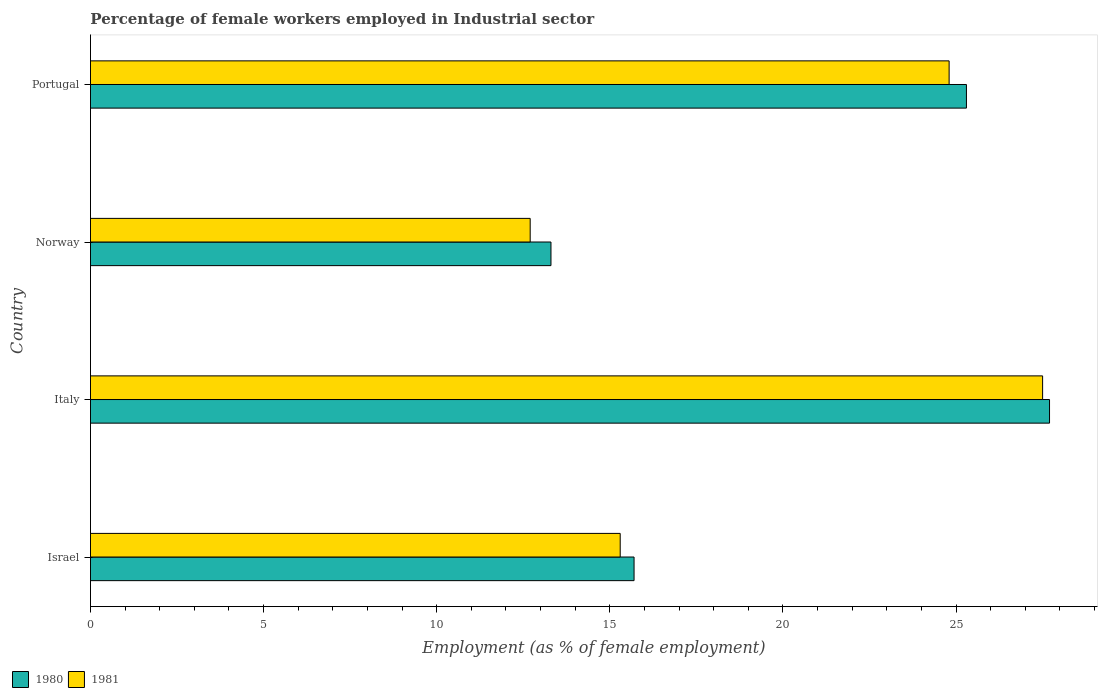Are the number of bars per tick equal to the number of legend labels?
Your response must be concise. Yes. Are the number of bars on each tick of the Y-axis equal?
Your response must be concise. Yes. What is the label of the 2nd group of bars from the top?
Make the answer very short. Norway. In how many cases, is the number of bars for a given country not equal to the number of legend labels?
Ensure brevity in your answer.  0. What is the percentage of females employed in Industrial sector in 1980 in Israel?
Your response must be concise. 15.7. Across all countries, what is the maximum percentage of females employed in Industrial sector in 1980?
Provide a succinct answer. 27.7. Across all countries, what is the minimum percentage of females employed in Industrial sector in 1981?
Give a very brief answer. 12.7. In which country was the percentage of females employed in Industrial sector in 1980 maximum?
Your response must be concise. Italy. What is the total percentage of females employed in Industrial sector in 1981 in the graph?
Make the answer very short. 80.3. What is the difference between the percentage of females employed in Industrial sector in 1981 in Israel and that in Italy?
Offer a very short reply. -12.2. What is the average percentage of females employed in Industrial sector in 1981 per country?
Ensure brevity in your answer.  20.07. What is the difference between the percentage of females employed in Industrial sector in 1981 and percentage of females employed in Industrial sector in 1980 in Israel?
Offer a very short reply. -0.4. In how many countries, is the percentage of females employed in Industrial sector in 1980 greater than 18 %?
Offer a very short reply. 2. What is the ratio of the percentage of females employed in Industrial sector in 1980 in Israel to that in Italy?
Your response must be concise. 0.57. What is the difference between the highest and the second highest percentage of females employed in Industrial sector in 1981?
Your response must be concise. 2.7. What is the difference between the highest and the lowest percentage of females employed in Industrial sector in 1980?
Your response must be concise. 14.4. What does the 2nd bar from the bottom in Italy represents?
Keep it short and to the point. 1981. Are all the bars in the graph horizontal?
Give a very brief answer. Yes. Does the graph contain grids?
Your response must be concise. No. How are the legend labels stacked?
Provide a short and direct response. Horizontal. What is the title of the graph?
Provide a succinct answer. Percentage of female workers employed in Industrial sector. What is the label or title of the X-axis?
Offer a very short reply. Employment (as % of female employment). What is the Employment (as % of female employment) in 1980 in Israel?
Give a very brief answer. 15.7. What is the Employment (as % of female employment) of 1981 in Israel?
Provide a short and direct response. 15.3. What is the Employment (as % of female employment) in 1980 in Italy?
Offer a very short reply. 27.7. What is the Employment (as % of female employment) in 1980 in Norway?
Provide a short and direct response. 13.3. What is the Employment (as % of female employment) in 1981 in Norway?
Provide a succinct answer. 12.7. What is the Employment (as % of female employment) of 1980 in Portugal?
Keep it short and to the point. 25.3. What is the Employment (as % of female employment) in 1981 in Portugal?
Provide a short and direct response. 24.8. Across all countries, what is the maximum Employment (as % of female employment) in 1980?
Give a very brief answer. 27.7. Across all countries, what is the minimum Employment (as % of female employment) in 1980?
Your answer should be compact. 13.3. Across all countries, what is the minimum Employment (as % of female employment) of 1981?
Make the answer very short. 12.7. What is the total Employment (as % of female employment) in 1980 in the graph?
Your answer should be very brief. 82. What is the total Employment (as % of female employment) in 1981 in the graph?
Your response must be concise. 80.3. What is the difference between the Employment (as % of female employment) in 1981 in Israel and that in Italy?
Give a very brief answer. -12.2. What is the difference between the Employment (as % of female employment) in 1980 in Israel and that in Norway?
Provide a succinct answer. 2.4. What is the difference between the Employment (as % of female employment) in 1980 in Israel and that in Portugal?
Provide a short and direct response. -9.6. What is the difference between the Employment (as % of female employment) in 1981 in Israel and that in Portugal?
Make the answer very short. -9.5. What is the difference between the Employment (as % of female employment) in 1981 in Italy and that in Norway?
Offer a very short reply. 14.8. What is the difference between the Employment (as % of female employment) in 1980 in Italy and that in Portugal?
Offer a terse response. 2.4. What is the difference between the Employment (as % of female employment) in 1981 in Italy and that in Portugal?
Your response must be concise. 2.7. What is the difference between the Employment (as % of female employment) in 1980 in Norway and that in Portugal?
Offer a terse response. -12. What is the difference between the Employment (as % of female employment) in 1980 in Israel and the Employment (as % of female employment) in 1981 in Italy?
Offer a terse response. -11.8. What is the difference between the Employment (as % of female employment) in 1980 in Israel and the Employment (as % of female employment) in 1981 in Portugal?
Offer a very short reply. -9.1. What is the difference between the Employment (as % of female employment) in 1980 in Italy and the Employment (as % of female employment) in 1981 in Norway?
Your answer should be compact. 15. What is the difference between the Employment (as % of female employment) of 1980 in Norway and the Employment (as % of female employment) of 1981 in Portugal?
Make the answer very short. -11.5. What is the average Employment (as % of female employment) in 1980 per country?
Your response must be concise. 20.5. What is the average Employment (as % of female employment) in 1981 per country?
Provide a short and direct response. 20.07. What is the difference between the Employment (as % of female employment) of 1980 and Employment (as % of female employment) of 1981 in Israel?
Give a very brief answer. 0.4. What is the difference between the Employment (as % of female employment) in 1980 and Employment (as % of female employment) in 1981 in Portugal?
Ensure brevity in your answer.  0.5. What is the ratio of the Employment (as % of female employment) in 1980 in Israel to that in Italy?
Provide a short and direct response. 0.57. What is the ratio of the Employment (as % of female employment) of 1981 in Israel to that in Italy?
Ensure brevity in your answer.  0.56. What is the ratio of the Employment (as % of female employment) of 1980 in Israel to that in Norway?
Provide a succinct answer. 1.18. What is the ratio of the Employment (as % of female employment) of 1981 in Israel to that in Norway?
Ensure brevity in your answer.  1.2. What is the ratio of the Employment (as % of female employment) in 1980 in Israel to that in Portugal?
Your response must be concise. 0.62. What is the ratio of the Employment (as % of female employment) of 1981 in Israel to that in Portugal?
Your answer should be very brief. 0.62. What is the ratio of the Employment (as % of female employment) of 1980 in Italy to that in Norway?
Provide a succinct answer. 2.08. What is the ratio of the Employment (as % of female employment) of 1981 in Italy to that in Norway?
Your response must be concise. 2.17. What is the ratio of the Employment (as % of female employment) of 1980 in Italy to that in Portugal?
Keep it short and to the point. 1.09. What is the ratio of the Employment (as % of female employment) of 1981 in Italy to that in Portugal?
Provide a short and direct response. 1.11. What is the ratio of the Employment (as % of female employment) in 1980 in Norway to that in Portugal?
Your response must be concise. 0.53. What is the ratio of the Employment (as % of female employment) in 1981 in Norway to that in Portugal?
Ensure brevity in your answer.  0.51. What is the difference between the highest and the lowest Employment (as % of female employment) of 1980?
Your response must be concise. 14.4. 